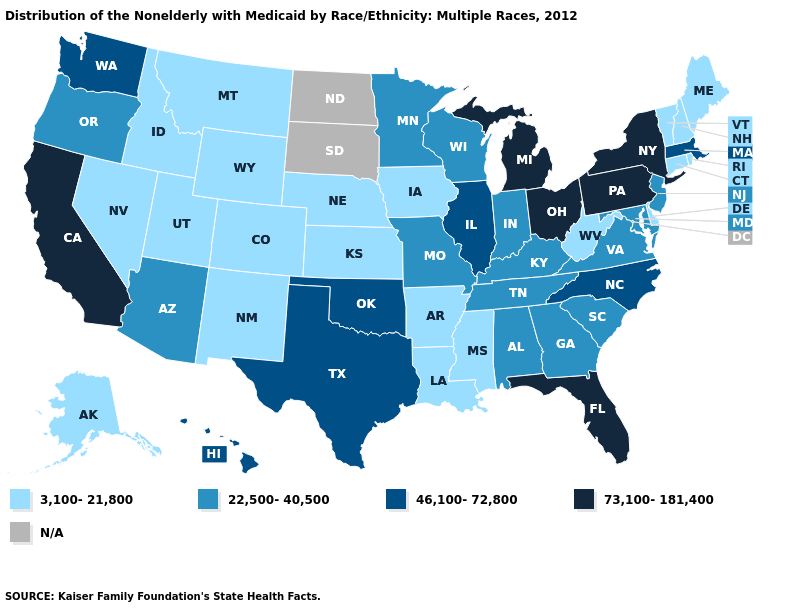What is the highest value in the South ?
Give a very brief answer. 73,100-181,400. Does the first symbol in the legend represent the smallest category?
Quick response, please. Yes. What is the value of South Dakota?
Answer briefly. N/A. Which states have the lowest value in the USA?
Answer briefly. Alaska, Arkansas, Colorado, Connecticut, Delaware, Idaho, Iowa, Kansas, Louisiana, Maine, Mississippi, Montana, Nebraska, Nevada, New Hampshire, New Mexico, Rhode Island, Utah, Vermont, West Virginia, Wyoming. What is the value of West Virginia?
Write a very short answer. 3,100-21,800. What is the highest value in states that border Kansas?
Give a very brief answer. 46,100-72,800. What is the value of Missouri?
Quick response, please. 22,500-40,500. Name the states that have a value in the range 46,100-72,800?
Write a very short answer. Hawaii, Illinois, Massachusetts, North Carolina, Oklahoma, Texas, Washington. What is the value of Arkansas?
Answer briefly. 3,100-21,800. Is the legend a continuous bar?
Concise answer only. No. Does the first symbol in the legend represent the smallest category?
Answer briefly. Yes. Which states have the highest value in the USA?
Answer briefly. California, Florida, Michigan, New York, Ohio, Pennsylvania. 